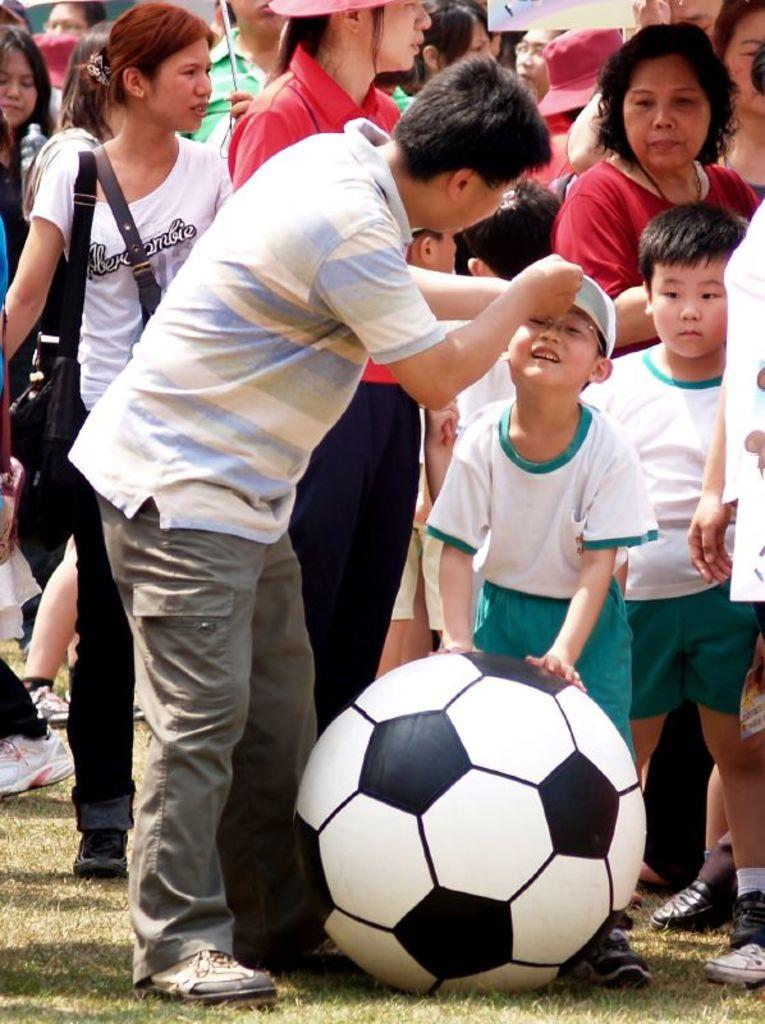What is the main activity taking place in the image? There are people on the grass in the image, suggesting they might be engaged in an outdoor activity. Can you describe any specific individuals in the image? Yes, there is a boy in the image. What is the boy holding in the image? The boy is holding a ball. Can you tell me how many kittens are playing baseball with the boy in the image? There are no kittens or baseball present in the image; it features people on the grass and a boy holding a ball. What type of zebra can be seen interacting with the boy and the ball in the image? There is no zebra present in the image; it only features people on the grass and a boy holding a ball. 